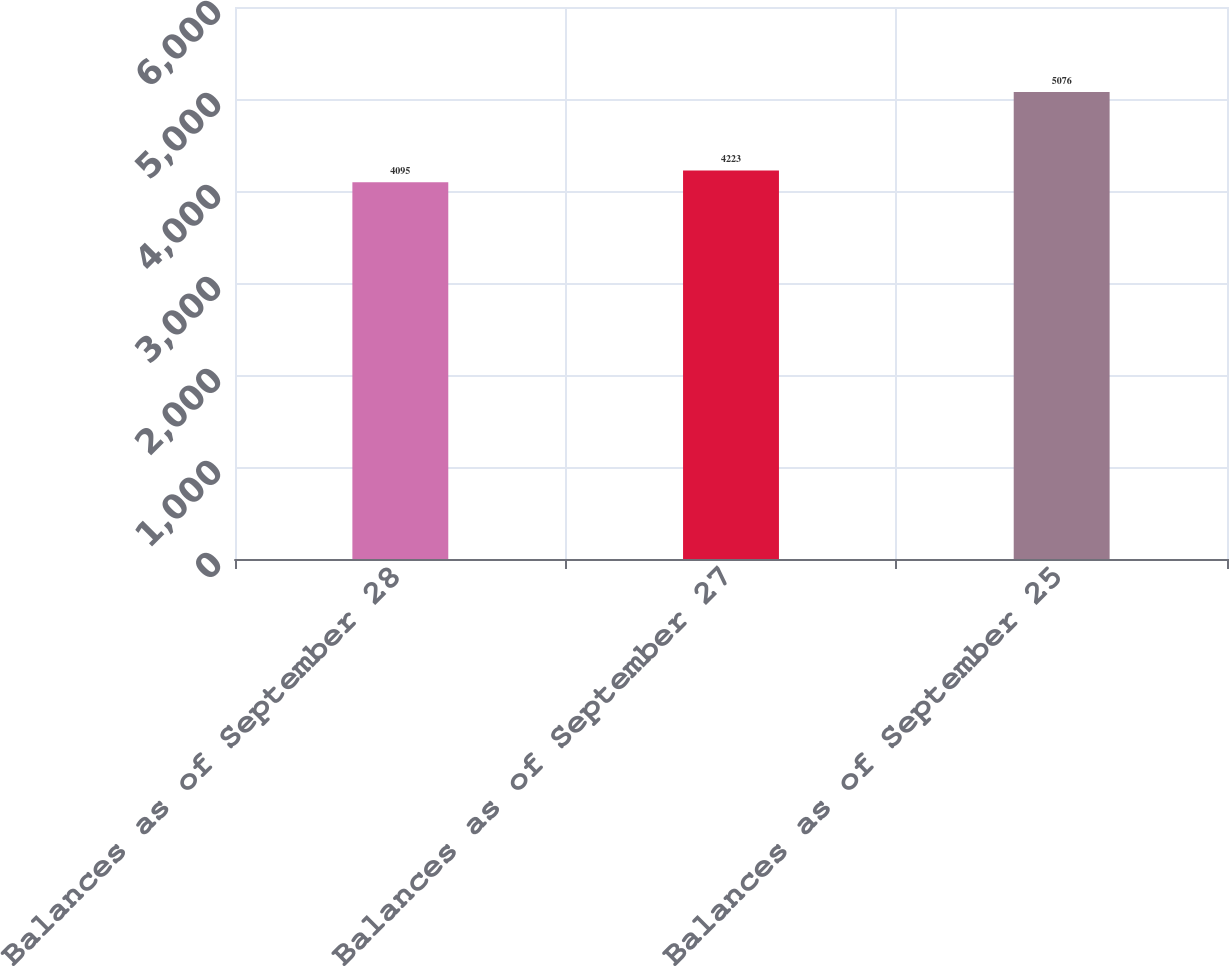<chart> <loc_0><loc_0><loc_500><loc_500><bar_chart><fcel>Balances as of September 28<fcel>Balances as of September 27<fcel>Balances as of September 25<nl><fcel>4095<fcel>4223<fcel>5076<nl></chart> 